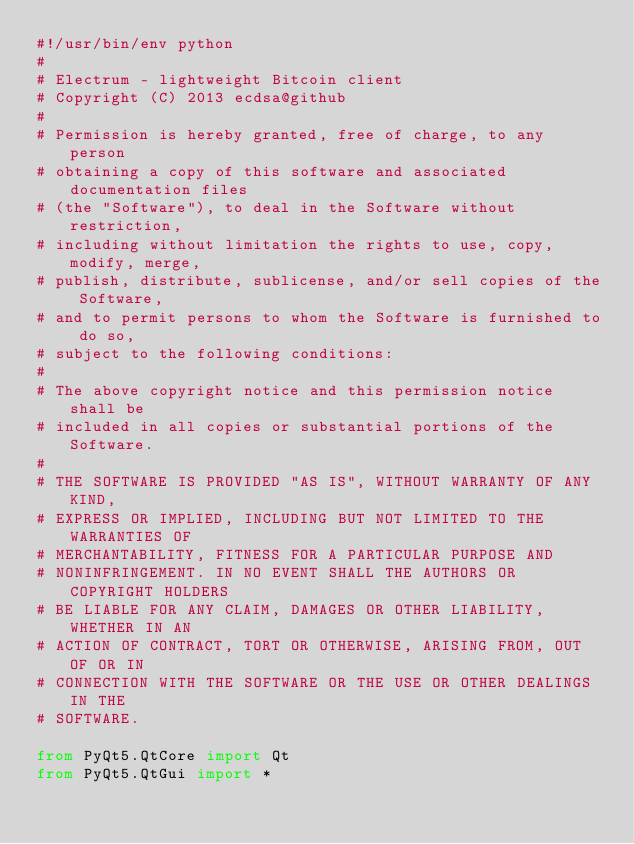Convert code to text. <code><loc_0><loc_0><loc_500><loc_500><_Python_>#!/usr/bin/env python
#
# Electrum - lightweight Bitcoin client
# Copyright (C) 2013 ecdsa@github
#
# Permission is hereby granted, free of charge, to any person
# obtaining a copy of this software and associated documentation files
# (the "Software"), to deal in the Software without restriction,
# including without limitation the rights to use, copy, modify, merge,
# publish, distribute, sublicense, and/or sell copies of the Software,
# and to permit persons to whom the Software is furnished to do so,
# subject to the following conditions:
#
# The above copyright notice and this permission notice shall be
# included in all copies or substantial portions of the Software.
#
# THE SOFTWARE IS PROVIDED "AS IS", WITHOUT WARRANTY OF ANY KIND,
# EXPRESS OR IMPLIED, INCLUDING BUT NOT LIMITED TO THE WARRANTIES OF
# MERCHANTABILITY, FITNESS FOR A PARTICULAR PURPOSE AND
# NONINFRINGEMENT. IN NO EVENT SHALL THE AUTHORS OR COPYRIGHT HOLDERS
# BE LIABLE FOR ANY CLAIM, DAMAGES OR OTHER LIABILITY, WHETHER IN AN
# ACTION OF CONTRACT, TORT OR OTHERWISE, ARISING FROM, OUT OF OR IN
# CONNECTION WITH THE SOFTWARE OR THE USE OR OTHER DEALINGS IN THE
# SOFTWARE.

from PyQt5.QtCore import Qt
from PyQt5.QtGui import *</code> 